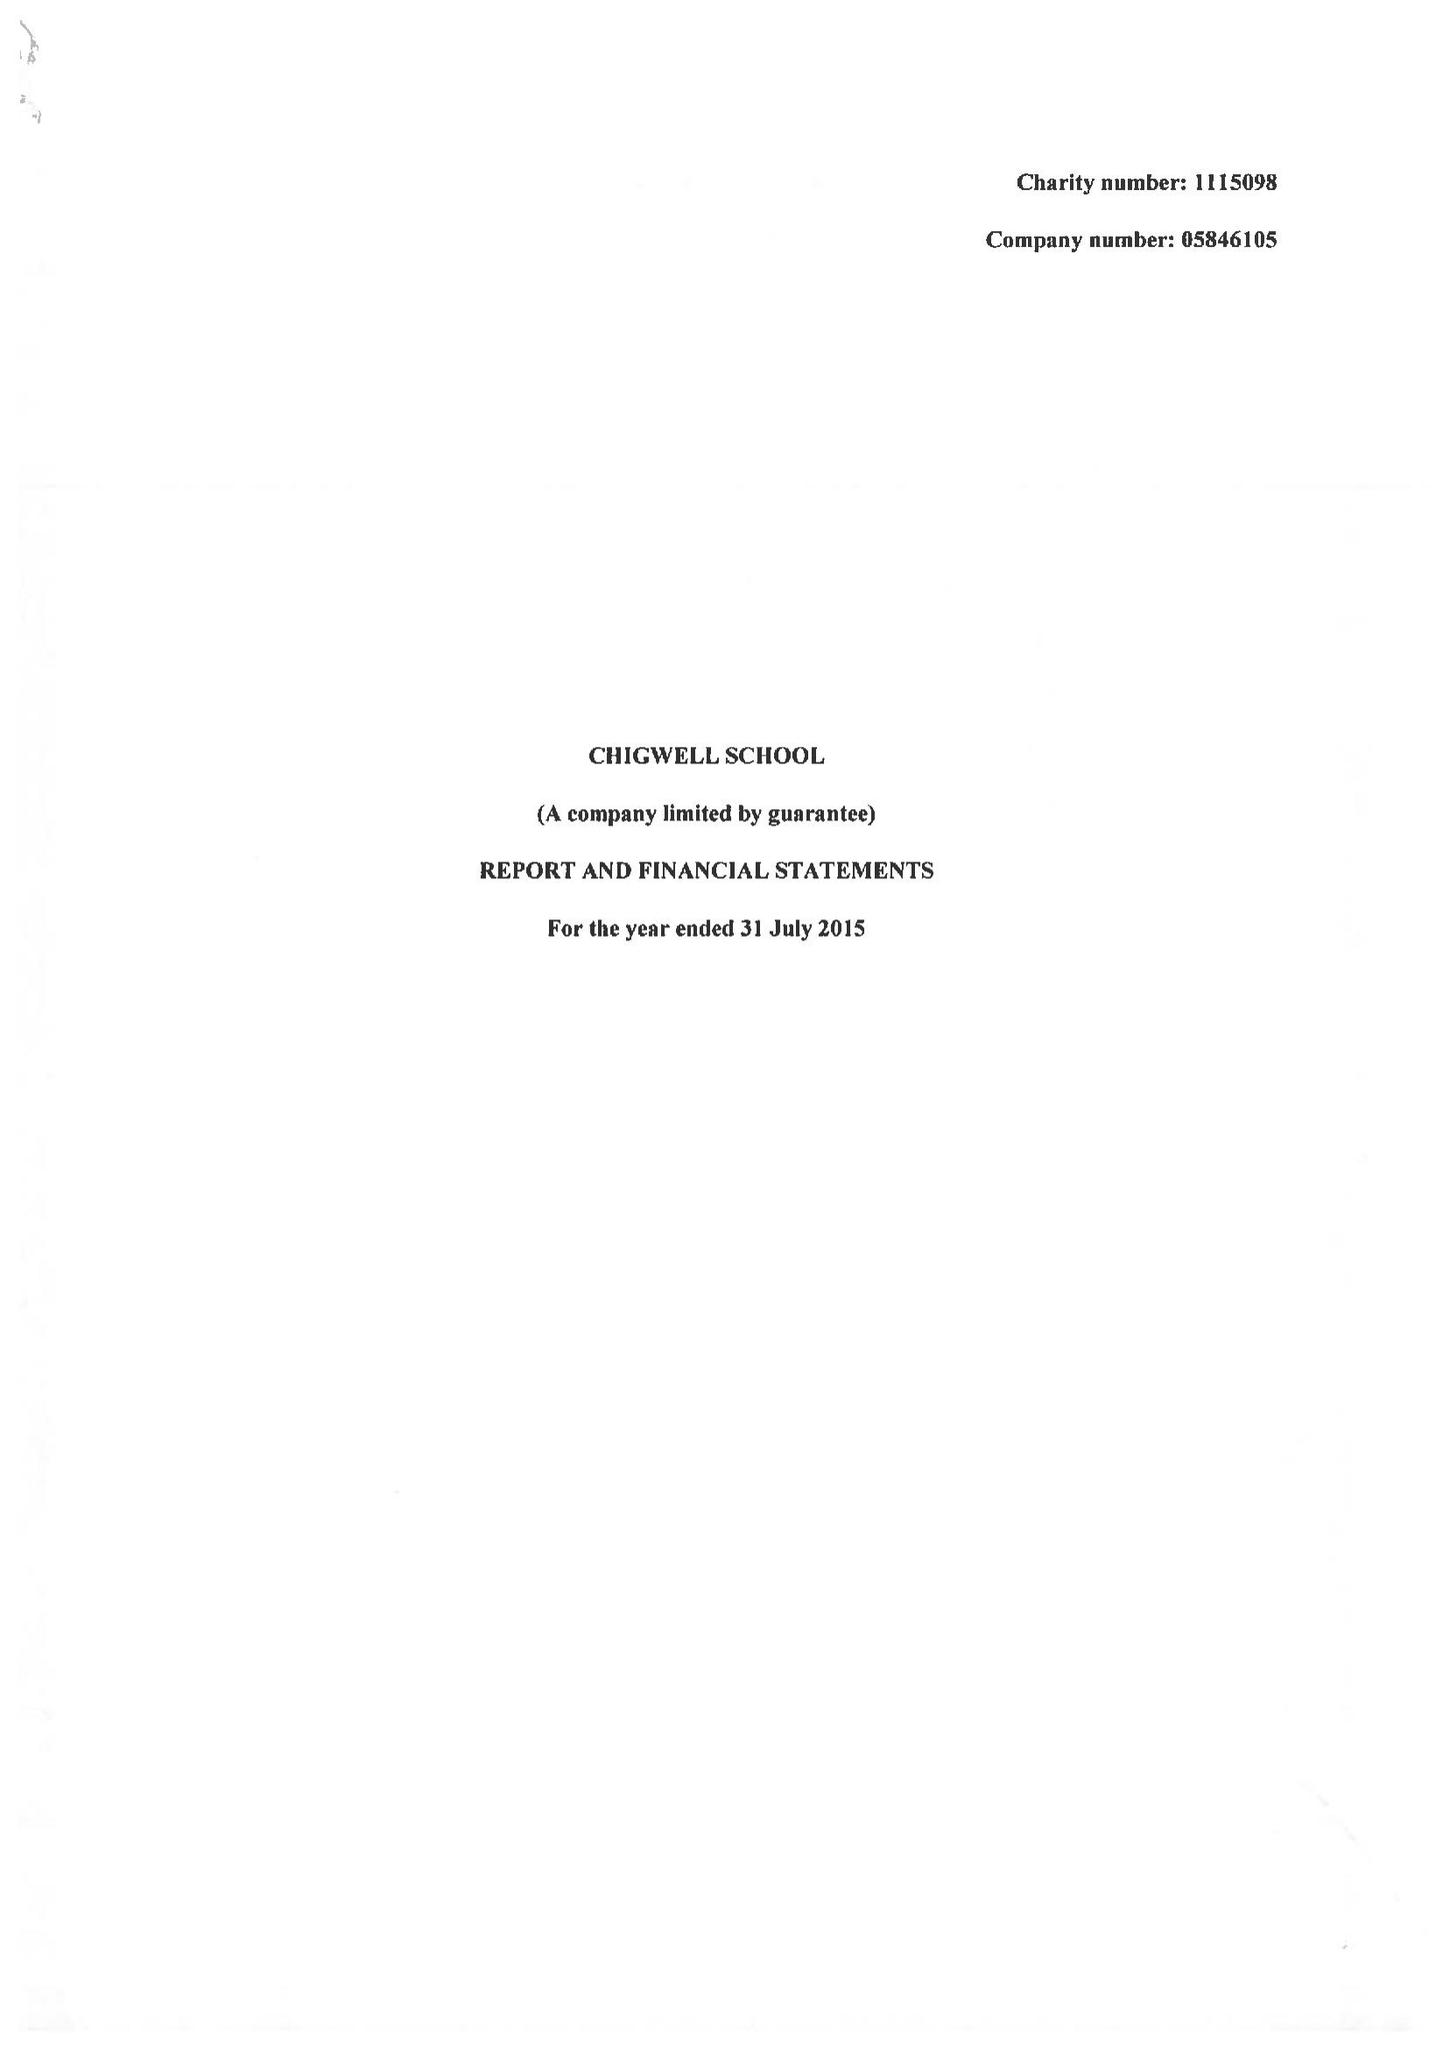What is the value for the address__post_town?
Answer the question using a single word or phrase. CHIGWELL 